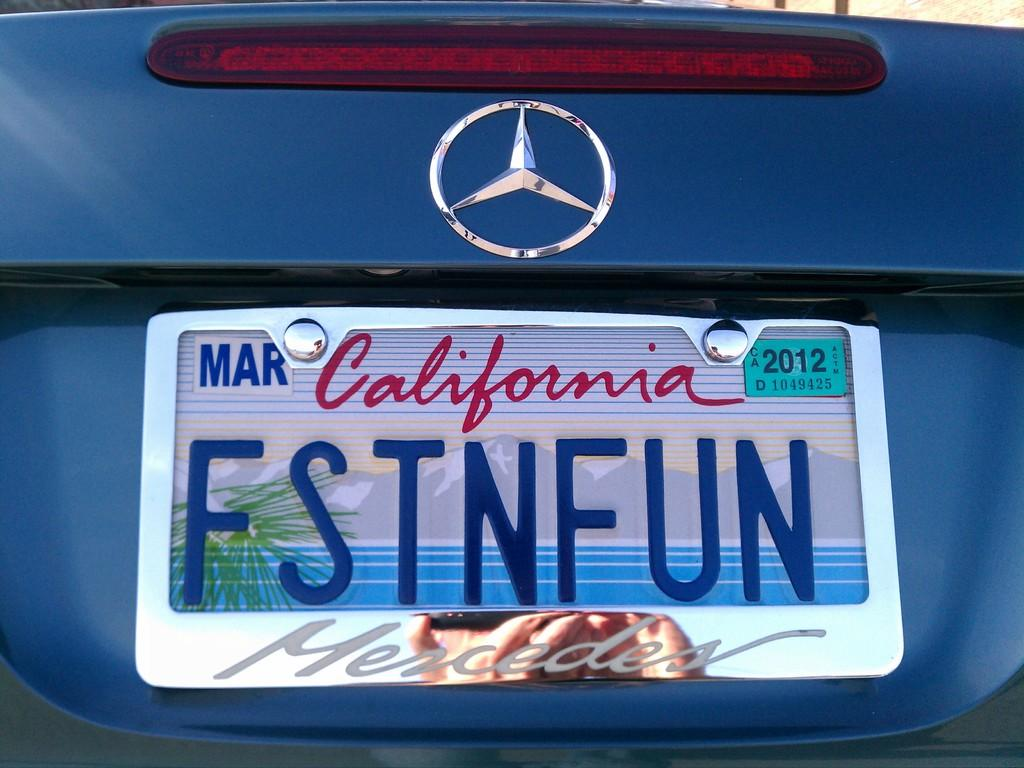<image>
Write a terse but informative summary of the picture. a California license plate that is on a car 